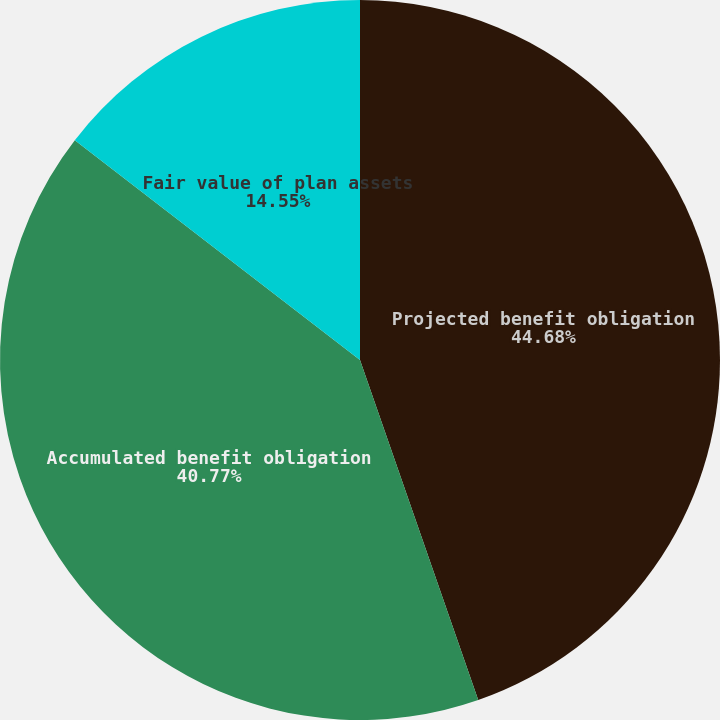<chart> <loc_0><loc_0><loc_500><loc_500><pie_chart><fcel>Projected benefit obligation<fcel>Accumulated benefit obligation<fcel>Fair value of plan assets<nl><fcel>44.67%<fcel>40.77%<fcel>14.55%<nl></chart> 